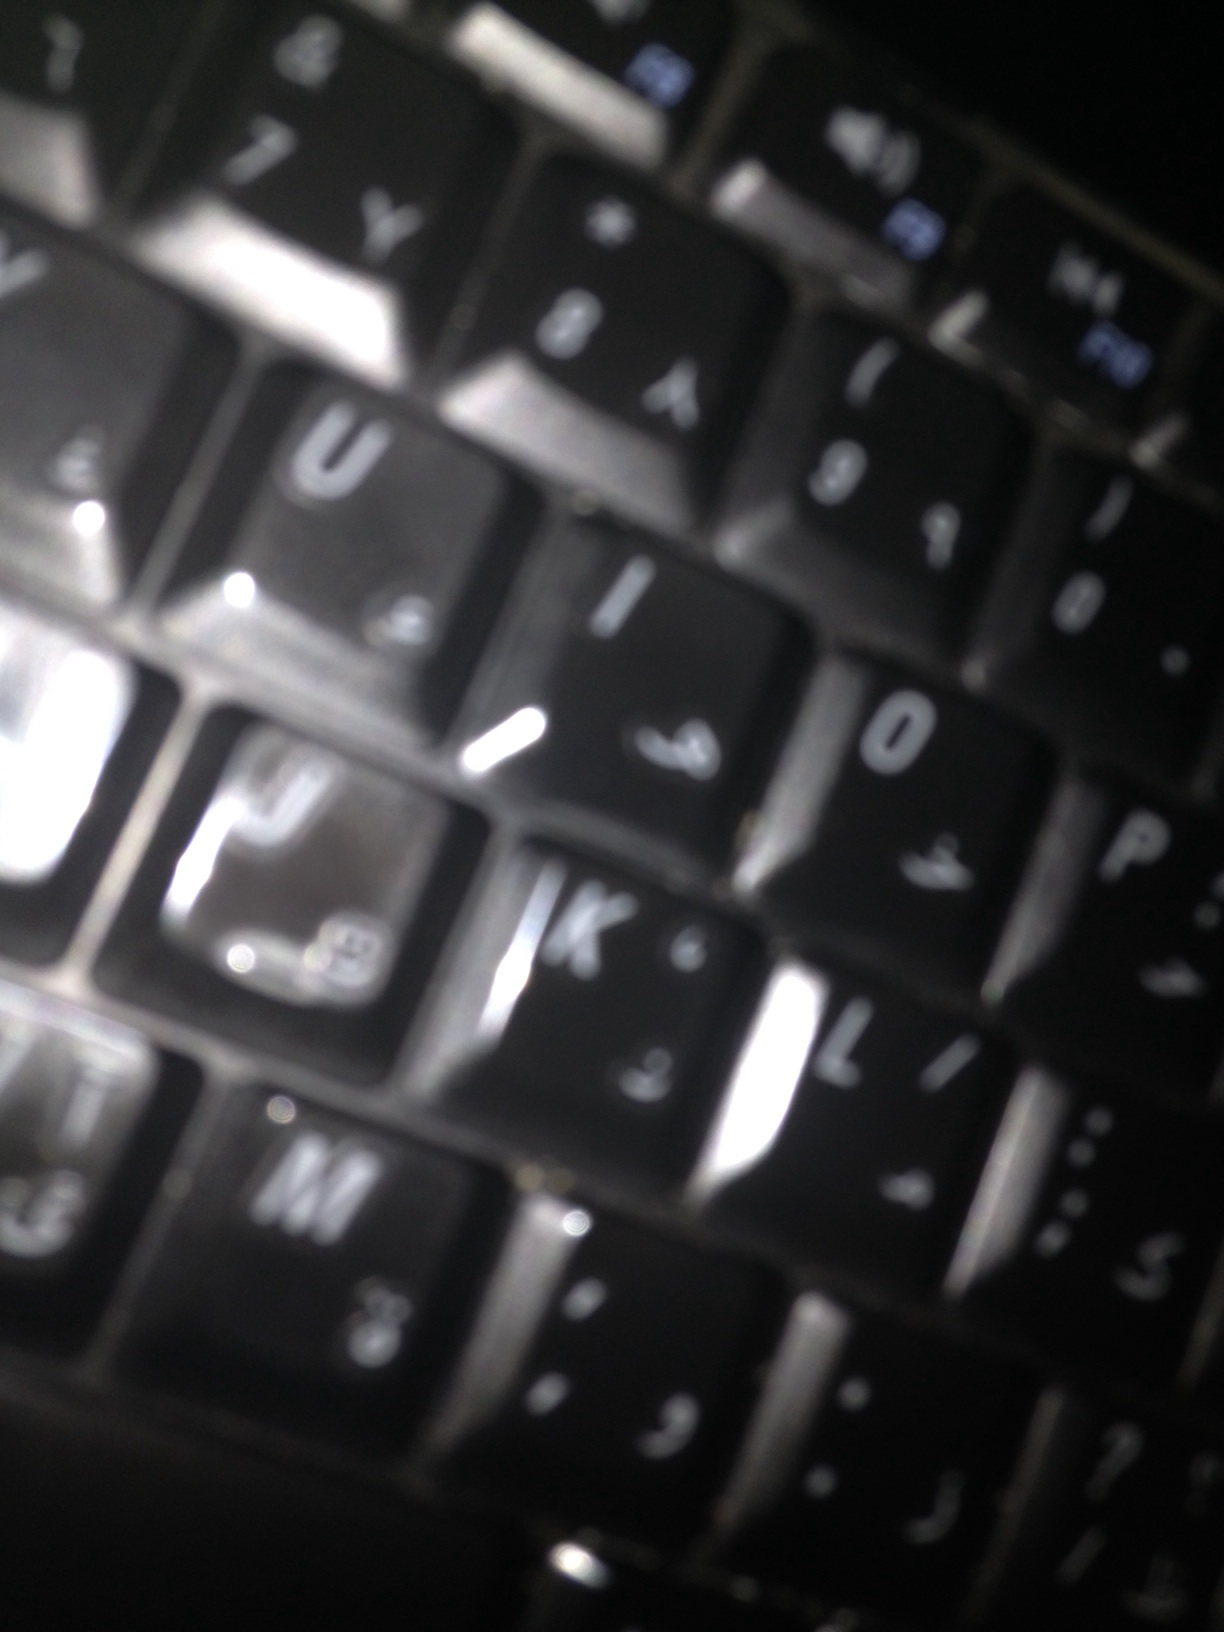Imagine you're writing a novel, and one of your characters is using this keyboard. What is a scene where this detail becomes significant? In a dimly lit room, Sarah sat at her desk, her fingers dancing across the keyboard. Each tap resonated with purpose as she translated ancient manuscripts. Her surroundings were cluttered with books and papers, a small window hinting at the night sky beyond. The keyboard, with its dual-language setup, was her link to both the past and the present. It had become an extension of her thoughts, and as she decoded the final, cryptic passage, the meaning of the centuries-old text became clear. It was a treasure map, and this keyboard had helped unlock its secrets. Little did she know, her discovery would lead her into an adventure beyond her wildest dreams, and the keyboard would remain her steadfast ally through the trials she was about to face. 